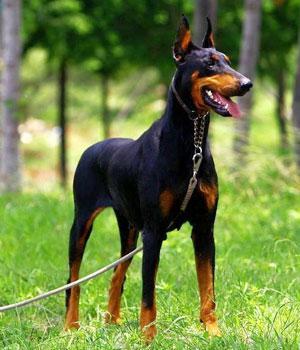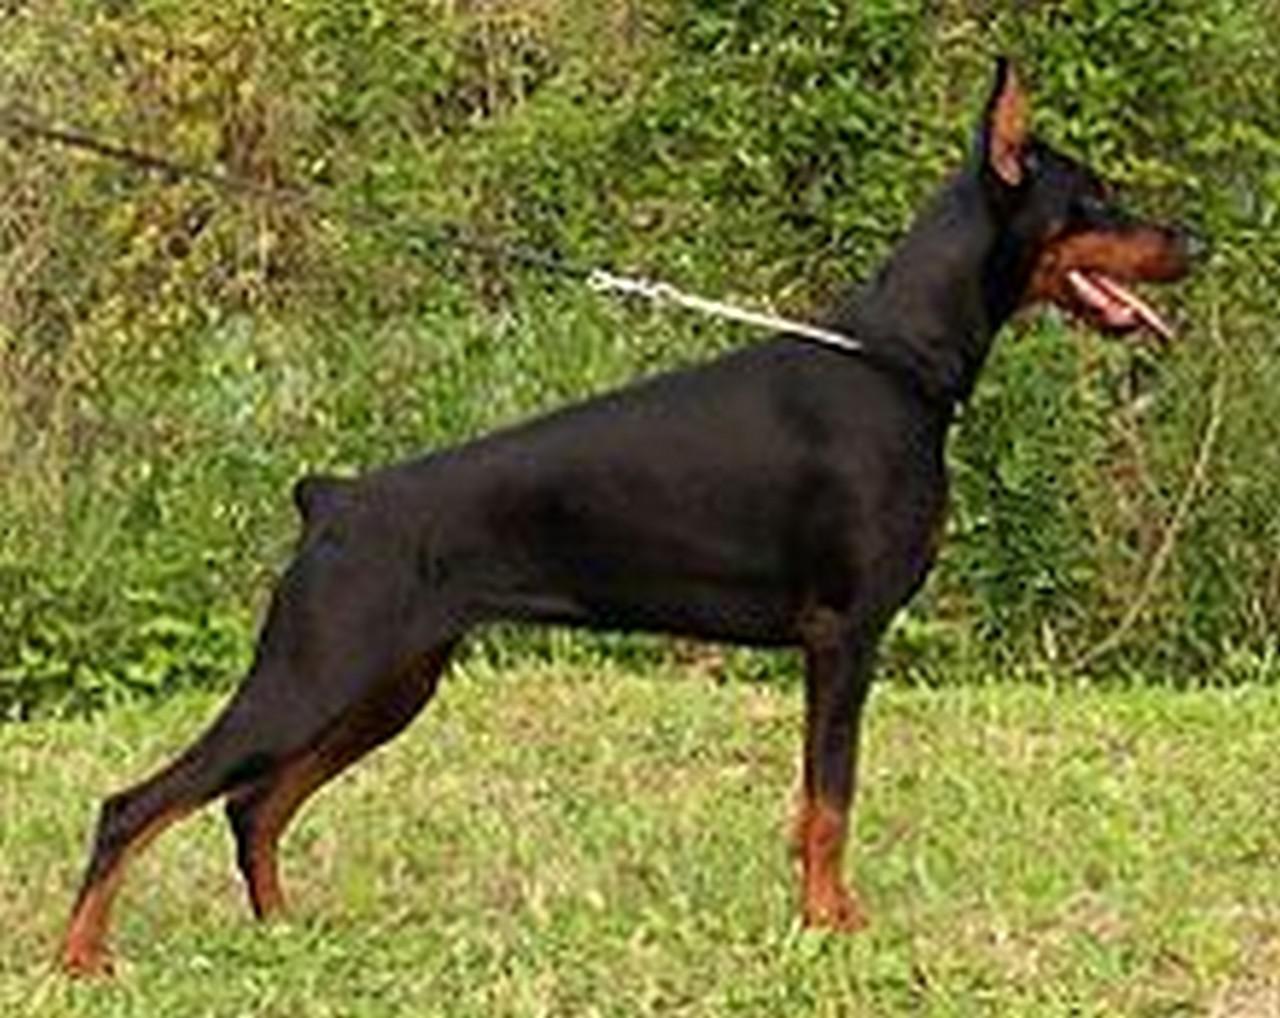The first image is the image on the left, the second image is the image on the right. For the images displayed, is the sentence "All of the dogs are facing directly to the camera." factually correct? Answer yes or no. No. The first image is the image on the left, the second image is the image on the right. Analyze the images presented: Is the assertion "One of the dobermans pictures has a black coat and one has a brown coat." valid? Answer yes or no. No. 